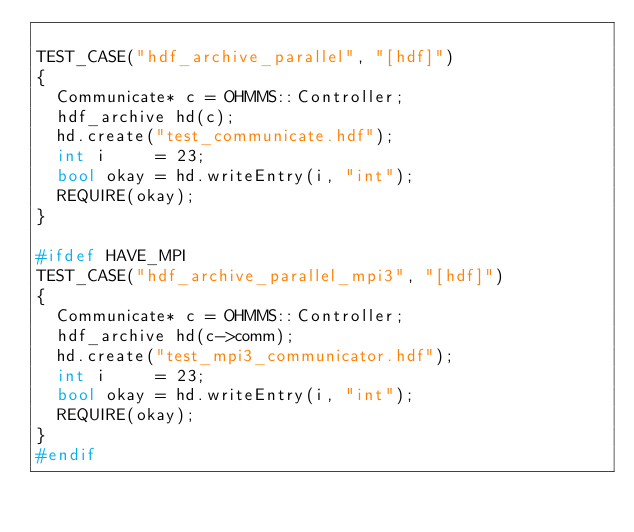Convert code to text. <code><loc_0><loc_0><loc_500><loc_500><_C++_>
TEST_CASE("hdf_archive_parallel", "[hdf]")
{
  Communicate* c = OHMMS::Controller;
  hdf_archive hd(c);
  hd.create("test_communicate.hdf");
  int i     = 23;
  bool okay = hd.writeEntry(i, "int");
  REQUIRE(okay);
}

#ifdef HAVE_MPI
TEST_CASE("hdf_archive_parallel_mpi3", "[hdf]")
{
  Communicate* c = OHMMS::Controller;
  hdf_archive hd(c->comm);
  hd.create("test_mpi3_communicator.hdf");
  int i     = 23;
  bool okay = hd.writeEntry(i, "int");
  REQUIRE(okay);
}
#endif
</code> 